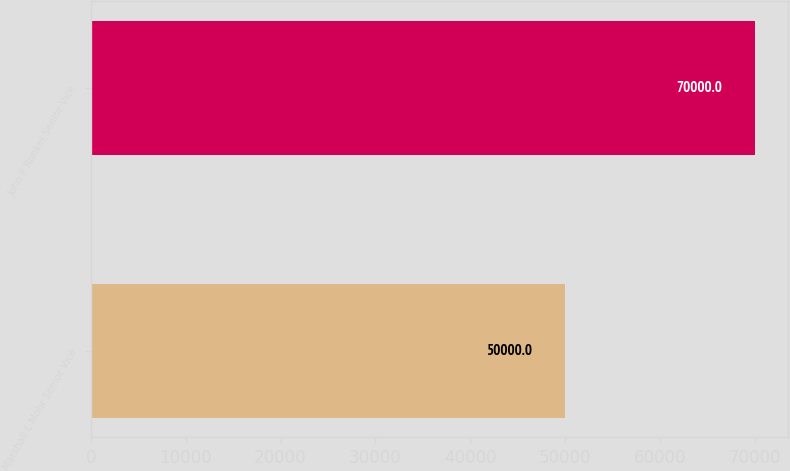Convert chart. <chart><loc_0><loc_0><loc_500><loc_500><bar_chart><fcel>Marshall L Mohr Senior Vice<fcel>John F Runkel Senior Vice<nl><fcel>50000<fcel>70000<nl></chart> 